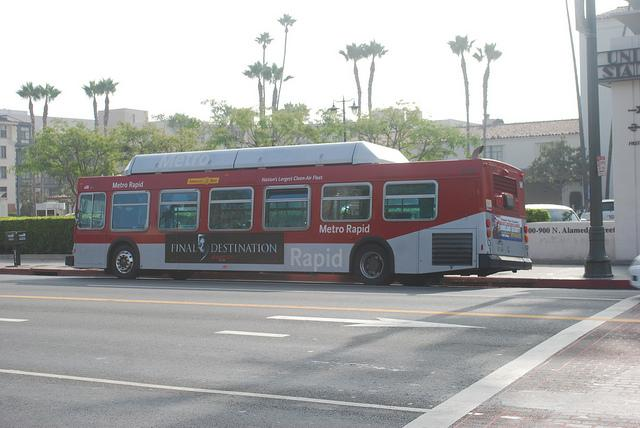What type of vehicle is this? Please explain your reasoning. passenger. This bus carries a lot of people. 